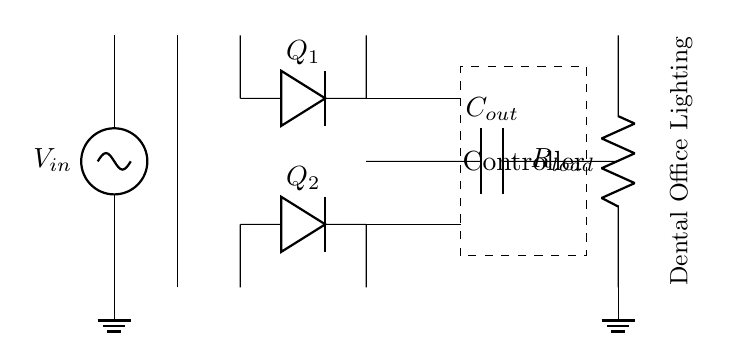What is the input voltage source labeled as? The input voltage source is labeled as V_in, indicating the voltage supplied to the circuit.
Answer: V_in What type of transformer is used in the circuit? The circuit includes a transformer core, which is a key component for stepping up or down voltage levels.
Answer: Transformer core How many diodes are in the bridge rectifier? The bridge rectifier contains two diodes labeled as Q1 and Q2, which work together to convert AC to DC.
Answer: 2 What component is used for filtering the output voltage? The circuit uses a capacitor labeled as C_out, designed to smooth the output voltage after rectification.
Answer: C_out What is the load represented in the circuit diagram? The load in the circuit is represented by a resistor labeled as R_load, which indicates the consumer of electrical power.
Answer: R_load What is the function of the controller in this circuit? The controller is responsible for managing the operation of the diodes and ensuring the synchronous rectification process is efficient.
Answer: Management How do the gate drivers connect the controller to the diodes? The gate drivers connect the controller to the diodes Q1 and Q2 directly, enabling the control signals to turn the diodes on and off in synchronization with the input voltage.
Answer: Direct connection 